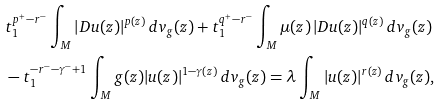Convert formula to latex. <formula><loc_0><loc_0><loc_500><loc_500>& t _ { 1 } ^ { p ^ { + } - r ^ { - } } \int _ { M } | D u ( z ) | ^ { p ( z ) } \, d v _ { g } ( z ) + t _ { 1 } ^ { q ^ { + } - r ^ { - } } \int _ { M } \mu ( z ) \, | D u ( z ) | ^ { q ( z ) } \, d v _ { g } ( z ) \\ & - t _ { 1 } ^ { - r ^ { - } - \gamma ^ { - } + 1 } \int _ { M } g ( z ) | u ( z ) | ^ { 1 - \gamma ( z ) } \, d v _ { g } ( z ) = \lambda \int _ { M } | u ( z ) | ^ { r ( z ) } \, d v _ { g } ( z ) ,</formula> 